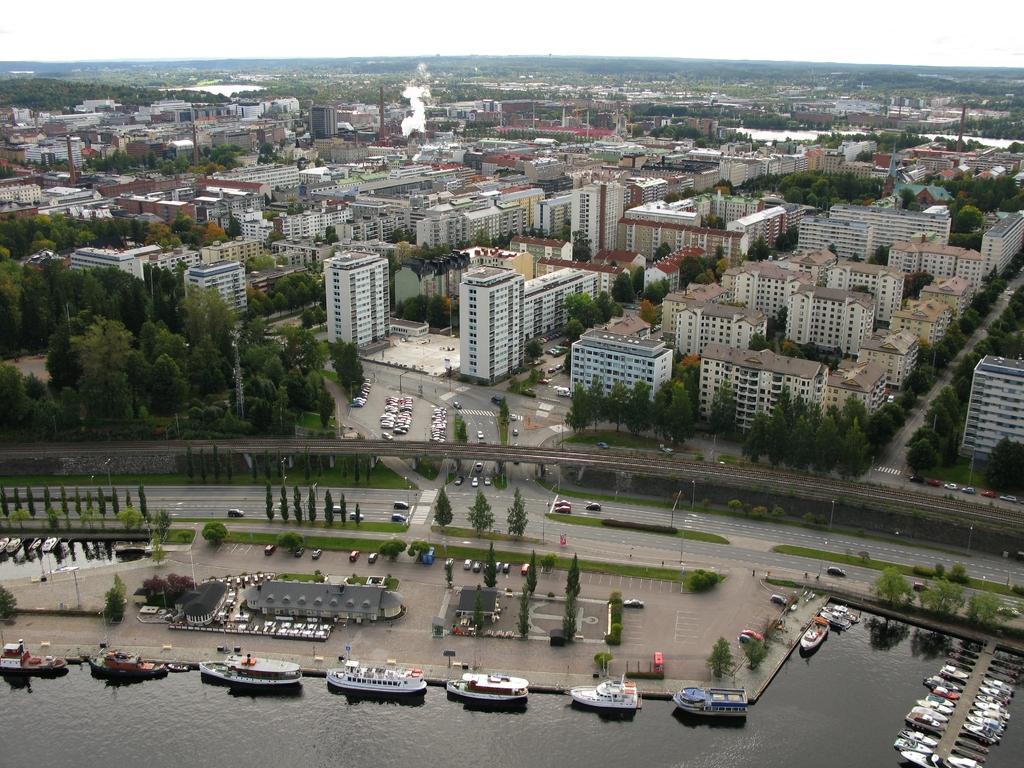Please provide a concise description of this image. We can see ships and boats above the water and vehicles on the road. We can see trees, buildings, poles, smoke and sky. 